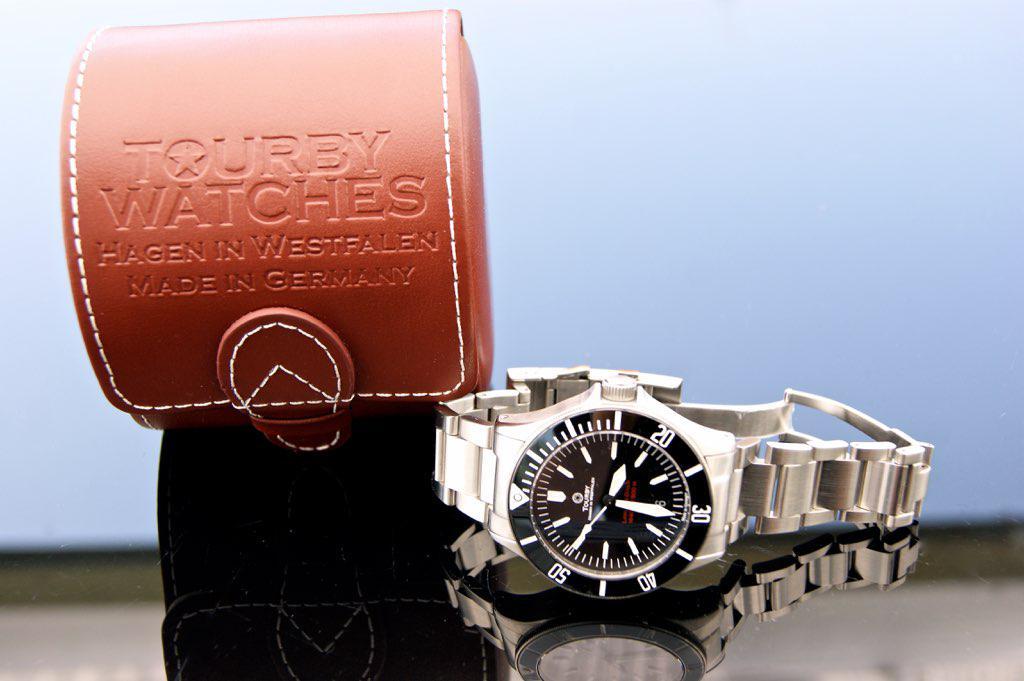What time is it on the watch?
Provide a succinct answer. 3:30. What country are these watchs made in?
Offer a terse response. Germany. 